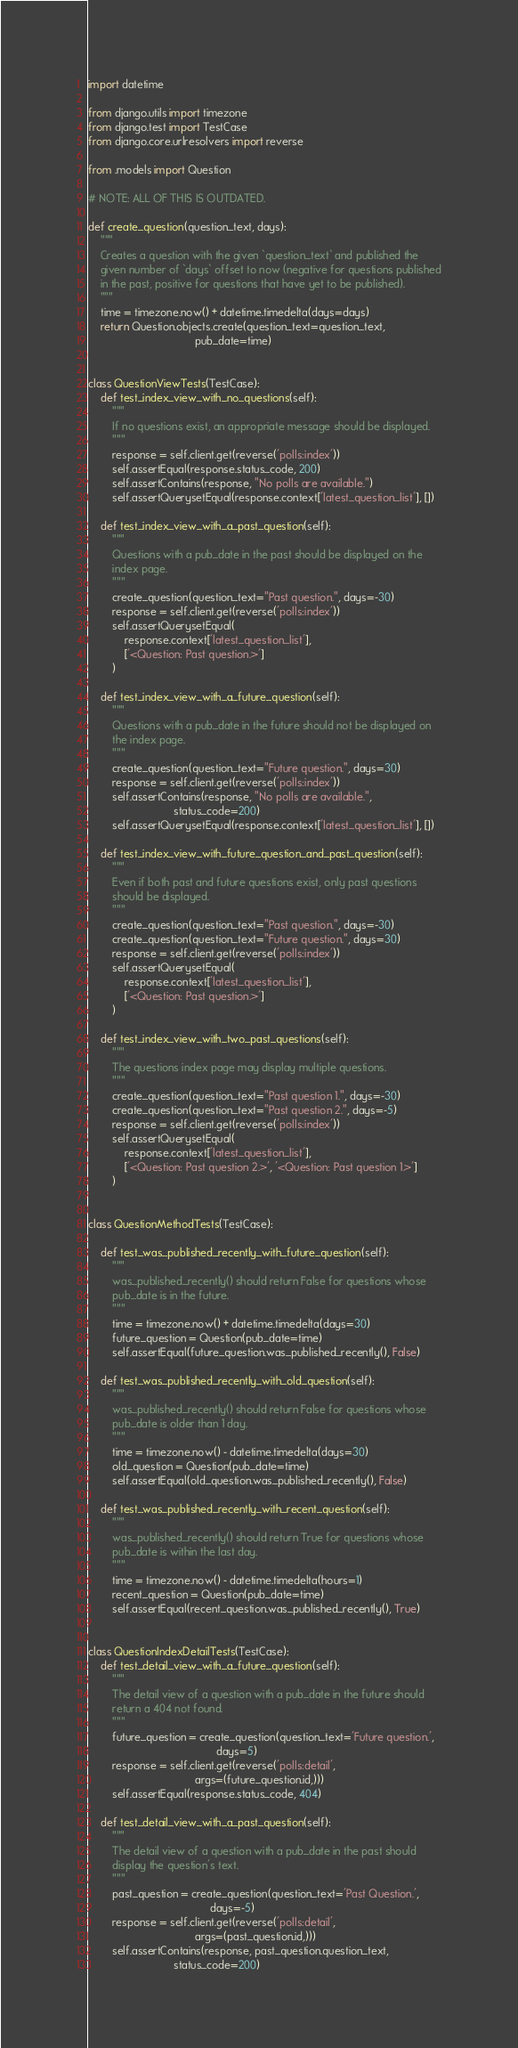<code> <loc_0><loc_0><loc_500><loc_500><_Python_>import datetime

from django.utils import timezone
from django.test import TestCase
from django.core.urlresolvers import reverse

from .models import Question

# NOTE: ALL OF THIS IS OUTDATED.

def create_question(question_text, days):
    """
    Creates a question with the given `question_text` and published the
    given number of `days` offset to now (negative for questions published
    in the past, positive for questions that have yet to be published).
    """
    time = timezone.now() + datetime.timedelta(days=days)
    return Question.objects.create(question_text=question_text,
                                   pub_date=time)


class QuestionViewTests(TestCase):
    def test_index_view_with_no_questions(self):
        """
        If no questions exist, an appropriate message should be displayed.
        """
        response = self.client.get(reverse('polls:index'))
        self.assertEqual(response.status_code, 200)
        self.assertContains(response, "No polls are available.")
        self.assertQuerysetEqual(response.context['latest_question_list'], [])

	def test_index_view_with_a_past_question(self):
		"""
        Questions with a pub_date in the past should be displayed on the
        index page.
        """
        create_question(question_text="Past question.", days=-30)
        response = self.client.get(reverse('polls:index'))
        self.assertQuerysetEqual(
            response.context['latest_question_list'],
            ['<Question: Past question.>']
        )

    def test_index_view_with_a_future_question(self):
        """
        Questions with a pub_date in the future should not be displayed on
        the index page.
        """
        create_question(question_text="Future question.", days=30)
        response = self.client.get(reverse('polls:index'))
        self.assertContains(response, "No polls are available.",
                            status_code=200)
        self.assertQuerysetEqual(response.context['latest_question_list'], [])

    def test_index_view_with_future_question_and_past_question(self):
        """
        Even if both past and future questions exist, only past questions
        should be displayed.
        """
        create_question(question_text="Past question.", days=-30)
        create_question(question_text="Future question.", days=30)
        response = self.client.get(reverse('polls:index'))
        self.assertQuerysetEqual(
            response.context['latest_question_list'],
            ['<Question: Past question.>']
        )

    def test_index_view_with_two_past_questions(self):
        """
        The questions index page may display multiple questions.
        """
        create_question(question_text="Past question 1.", days=-30)
        create_question(question_text="Past question 2.", days=-5)
        response = self.client.get(reverse('polls:index'))
        self.assertQuerysetEqual(
            response.context['latest_question_list'],
            ['<Question: Past question 2.>', '<Question: Past question 1.>']
        )


class QuestionMethodTests(TestCase):

    def test_was_published_recently_with_future_question(self):
        """
        was_published_recently() should return False for questions whose
        pub_date is in the future.
        """
        time = timezone.now() + datetime.timedelta(days=30)
        future_question = Question(pub_date=time)
        self.assertEqual(future_question.was_published_recently(), False)

	def test_was_published_recently_with_old_question(self):
	    """
	    was_published_recently() should return False for questions whose
	    pub_date is older than 1 day.
	    """
	    time = timezone.now() - datetime.timedelta(days=30)
	    old_question = Question(pub_date=time)
	    self.assertEqual(old_question.was_published_recently(), False)

	def test_was_published_recently_with_recent_question(self):
	    """
	    was_published_recently() should return True for questions whose
	    pub_date is within the last day.
	    """
	    time = timezone.now() - datetime.timedelta(hours=1)
	    recent_question = Question(pub_date=time)
	    self.assertEqual(recent_question.was_published_recently(), True)


class QuestionIndexDetailTests(TestCase):
    def test_detail_view_with_a_future_question(self):
        """
        The detail view of a question with a pub_date in the future should
        return a 404 not found.
        """
        future_question = create_question(question_text='Future question.',
                                          days=5)
        response = self.client.get(reverse('polls:detail',
                                   args=(future_question.id,)))
        self.assertEqual(response.status_code, 404)

    def test_detail_view_with_a_past_question(self):
        """
        The detail view of a question with a pub_date in the past should
        display the question's text.
        """
        past_question = create_question(question_text='Past Question.',
                                        days=-5)
        response = self.client.get(reverse('polls:detail',
                                   args=(past_question.id,)))
        self.assertContains(response, past_question.question_text,
                            status_code=200)</code> 